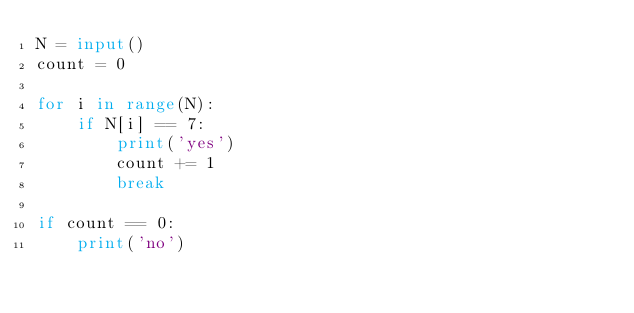<code> <loc_0><loc_0><loc_500><loc_500><_Python_>N = input()
count = 0

for i in range(N):
    if N[i] == 7:
        print('yes')
        count += 1
        break
    
if count == 0:
    print('no')</code> 